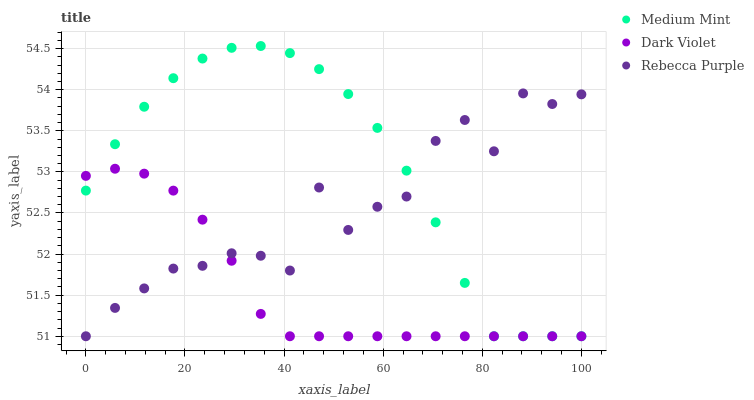Does Dark Violet have the minimum area under the curve?
Answer yes or no. Yes. Does Medium Mint have the maximum area under the curve?
Answer yes or no. Yes. Does Rebecca Purple have the minimum area under the curve?
Answer yes or no. No. Does Rebecca Purple have the maximum area under the curve?
Answer yes or no. No. Is Dark Violet the smoothest?
Answer yes or no. Yes. Is Rebecca Purple the roughest?
Answer yes or no. Yes. Is Rebecca Purple the smoothest?
Answer yes or no. No. Is Dark Violet the roughest?
Answer yes or no. No. Does Medium Mint have the lowest value?
Answer yes or no. Yes. Does Medium Mint have the highest value?
Answer yes or no. Yes. Does Rebecca Purple have the highest value?
Answer yes or no. No. Does Dark Violet intersect Medium Mint?
Answer yes or no. Yes. Is Dark Violet less than Medium Mint?
Answer yes or no. No. Is Dark Violet greater than Medium Mint?
Answer yes or no. No. 